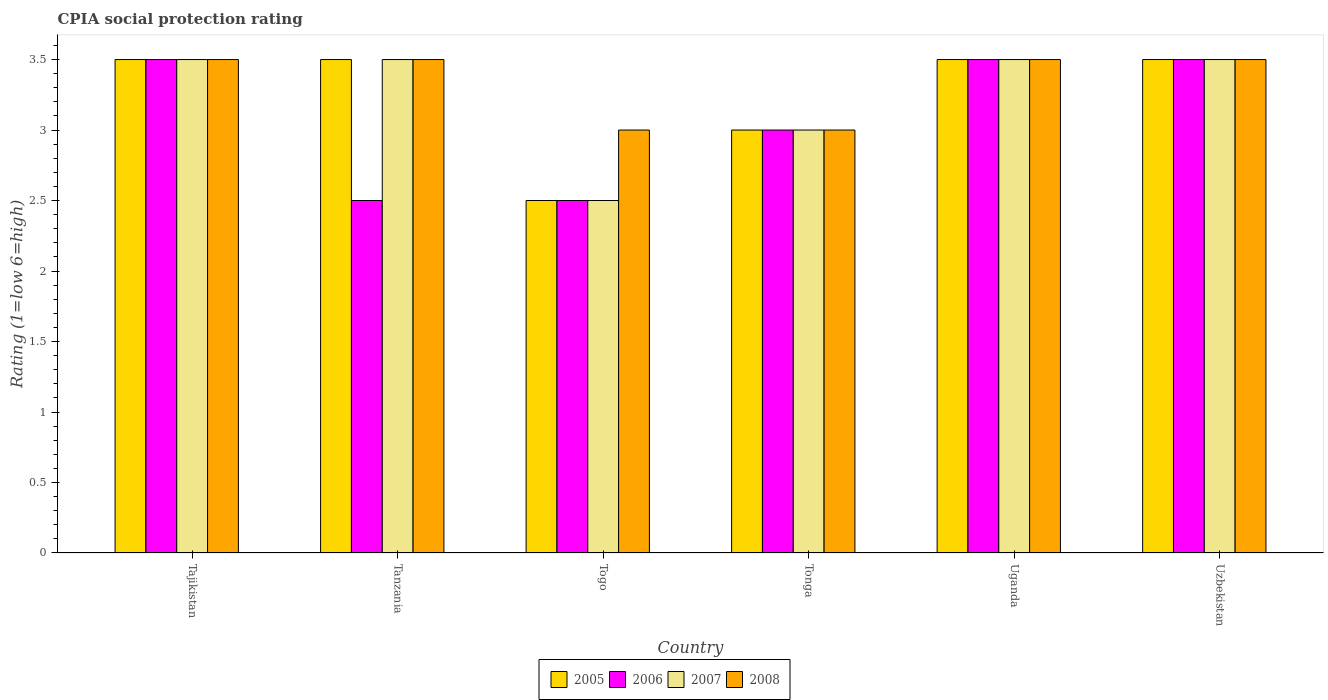How many groups of bars are there?
Ensure brevity in your answer.  6. How many bars are there on the 4th tick from the left?
Ensure brevity in your answer.  4. What is the label of the 2nd group of bars from the left?
Your response must be concise. Tanzania. In how many cases, is the number of bars for a given country not equal to the number of legend labels?
Your answer should be compact. 0. Across all countries, what is the maximum CPIA rating in 2005?
Provide a succinct answer. 3.5. Across all countries, what is the minimum CPIA rating in 2005?
Make the answer very short. 2.5. In which country was the CPIA rating in 2008 maximum?
Provide a succinct answer. Tajikistan. In which country was the CPIA rating in 2006 minimum?
Ensure brevity in your answer.  Tanzania. What is the average CPIA rating in 2007 per country?
Your answer should be very brief. 3.25. What is the difference between the CPIA rating of/in 2007 and CPIA rating of/in 2005 in Togo?
Keep it short and to the point. 0. In how many countries, is the CPIA rating in 2005 greater than 1.3?
Your response must be concise. 6. What is the ratio of the CPIA rating in 2007 in Togo to that in Uganda?
Offer a very short reply. 0.71. What is the difference between the highest and the lowest CPIA rating in 2005?
Your answer should be compact. 1. Is the sum of the CPIA rating in 2006 in Togo and Uganda greater than the maximum CPIA rating in 2005 across all countries?
Your answer should be compact. Yes. Is it the case that in every country, the sum of the CPIA rating in 2007 and CPIA rating in 2005 is greater than the sum of CPIA rating in 2006 and CPIA rating in 2008?
Your response must be concise. No. What does the 4th bar from the left in Uzbekistan represents?
Provide a succinct answer. 2008. What does the 3rd bar from the right in Tajikistan represents?
Offer a terse response. 2006. What is the difference between two consecutive major ticks on the Y-axis?
Give a very brief answer. 0.5. Are the values on the major ticks of Y-axis written in scientific E-notation?
Make the answer very short. No. Does the graph contain grids?
Your response must be concise. No. How are the legend labels stacked?
Ensure brevity in your answer.  Horizontal. What is the title of the graph?
Provide a succinct answer. CPIA social protection rating. What is the label or title of the X-axis?
Provide a succinct answer. Country. What is the Rating (1=low 6=high) in 2007 in Tajikistan?
Ensure brevity in your answer.  3.5. What is the Rating (1=low 6=high) of 2008 in Tajikistan?
Give a very brief answer. 3.5. What is the Rating (1=low 6=high) of 2008 in Tanzania?
Keep it short and to the point. 3.5. What is the Rating (1=low 6=high) in 2005 in Togo?
Ensure brevity in your answer.  2.5. What is the Rating (1=low 6=high) in 2008 in Togo?
Your answer should be compact. 3. What is the Rating (1=low 6=high) in 2006 in Tonga?
Keep it short and to the point. 3. What is the Rating (1=low 6=high) in 2007 in Tonga?
Give a very brief answer. 3. What is the Rating (1=low 6=high) in 2008 in Tonga?
Ensure brevity in your answer.  3. What is the Rating (1=low 6=high) in 2005 in Uganda?
Provide a succinct answer. 3.5. What is the Rating (1=low 6=high) of 2006 in Uganda?
Your answer should be very brief. 3.5. What is the Rating (1=low 6=high) of 2007 in Uganda?
Your answer should be very brief. 3.5. What is the Rating (1=low 6=high) in 2008 in Uganda?
Your response must be concise. 3.5. What is the Rating (1=low 6=high) of 2008 in Uzbekistan?
Provide a short and direct response. 3.5. Across all countries, what is the maximum Rating (1=low 6=high) of 2005?
Offer a terse response. 3.5. Across all countries, what is the maximum Rating (1=low 6=high) of 2007?
Offer a terse response. 3.5. Across all countries, what is the maximum Rating (1=low 6=high) in 2008?
Keep it short and to the point. 3.5. Across all countries, what is the minimum Rating (1=low 6=high) in 2005?
Offer a very short reply. 2.5. Across all countries, what is the minimum Rating (1=low 6=high) of 2006?
Keep it short and to the point. 2.5. Across all countries, what is the minimum Rating (1=low 6=high) in 2007?
Ensure brevity in your answer.  2.5. What is the total Rating (1=low 6=high) of 2005 in the graph?
Give a very brief answer. 19.5. What is the total Rating (1=low 6=high) of 2007 in the graph?
Make the answer very short. 19.5. What is the difference between the Rating (1=low 6=high) in 2005 in Tajikistan and that in Tanzania?
Offer a very short reply. 0. What is the difference between the Rating (1=low 6=high) in 2006 in Tajikistan and that in Tanzania?
Your answer should be compact. 1. What is the difference between the Rating (1=low 6=high) of 2008 in Tajikistan and that in Tanzania?
Give a very brief answer. 0. What is the difference between the Rating (1=low 6=high) of 2006 in Tajikistan and that in Togo?
Ensure brevity in your answer.  1. What is the difference between the Rating (1=low 6=high) of 2006 in Tajikistan and that in Tonga?
Give a very brief answer. 0.5. What is the difference between the Rating (1=low 6=high) in 2007 in Tajikistan and that in Tonga?
Your answer should be very brief. 0.5. What is the difference between the Rating (1=low 6=high) of 2008 in Tajikistan and that in Tonga?
Give a very brief answer. 0.5. What is the difference between the Rating (1=low 6=high) in 2005 in Tajikistan and that in Uganda?
Offer a very short reply. 0. What is the difference between the Rating (1=low 6=high) of 2006 in Tajikistan and that in Uganda?
Offer a very short reply. 0. What is the difference between the Rating (1=low 6=high) of 2007 in Tajikistan and that in Uganda?
Provide a succinct answer. 0. What is the difference between the Rating (1=low 6=high) in 2008 in Tajikistan and that in Uganda?
Your answer should be compact. 0. What is the difference between the Rating (1=low 6=high) in 2005 in Tajikistan and that in Uzbekistan?
Keep it short and to the point. 0. What is the difference between the Rating (1=low 6=high) in 2007 in Tajikistan and that in Uzbekistan?
Offer a terse response. 0. What is the difference between the Rating (1=low 6=high) of 2006 in Tanzania and that in Togo?
Your answer should be compact. 0. What is the difference between the Rating (1=low 6=high) in 2007 in Tanzania and that in Togo?
Make the answer very short. 1. What is the difference between the Rating (1=low 6=high) in 2008 in Tanzania and that in Togo?
Give a very brief answer. 0.5. What is the difference between the Rating (1=low 6=high) of 2007 in Tanzania and that in Tonga?
Offer a terse response. 0.5. What is the difference between the Rating (1=low 6=high) in 2006 in Tanzania and that in Uganda?
Offer a very short reply. -1. What is the difference between the Rating (1=low 6=high) in 2007 in Tanzania and that in Uganda?
Provide a short and direct response. 0. What is the difference between the Rating (1=low 6=high) of 2008 in Tanzania and that in Uganda?
Give a very brief answer. 0. What is the difference between the Rating (1=low 6=high) of 2008 in Togo and that in Tonga?
Give a very brief answer. 0. What is the difference between the Rating (1=low 6=high) of 2005 in Togo and that in Uzbekistan?
Give a very brief answer. -1. What is the difference between the Rating (1=low 6=high) in 2007 in Togo and that in Uzbekistan?
Keep it short and to the point. -1. What is the difference between the Rating (1=low 6=high) of 2008 in Togo and that in Uzbekistan?
Make the answer very short. -0.5. What is the difference between the Rating (1=low 6=high) of 2005 in Tonga and that in Uganda?
Your response must be concise. -0.5. What is the difference between the Rating (1=low 6=high) in 2007 in Tonga and that in Uganda?
Make the answer very short. -0.5. What is the difference between the Rating (1=low 6=high) in 2005 in Tonga and that in Uzbekistan?
Provide a succinct answer. -0.5. What is the difference between the Rating (1=low 6=high) in 2007 in Tonga and that in Uzbekistan?
Offer a very short reply. -0.5. What is the difference between the Rating (1=low 6=high) of 2005 in Uganda and that in Uzbekistan?
Make the answer very short. 0. What is the difference between the Rating (1=low 6=high) of 2006 in Uganda and that in Uzbekistan?
Your response must be concise. 0. What is the difference between the Rating (1=low 6=high) of 2006 in Tajikistan and the Rating (1=low 6=high) of 2007 in Tanzania?
Ensure brevity in your answer.  0. What is the difference between the Rating (1=low 6=high) of 2007 in Tajikistan and the Rating (1=low 6=high) of 2008 in Tanzania?
Give a very brief answer. 0. What is the difference between the Rating (1=low 6=high) of 2005 in Tajikistan and the Rating (1=low 6=high) of 2007 in Togo?
Make the answer very short. 1. What is the difference between the Rating (1=low 6=high) in 2005 in Tajikistan and the Rating (1=low 6=high) in 2008 in Togo?
Keep it short and to the point. 0.5. What is the difference between the Rating (1=low 6=high) of 2006 in Tajikistan and the Rating (1=low 6=high) of 2007 in Togo?
Provide a succinct answer. 1. What is the difference between the Rating (1=low 6=high) in 2006 in Tajikistan and the Rating (1=low 6=high) in 2008 in Togo?
Your answer should be very brief. 0.5. What is the difference between the Rating (1=low 6=high) of 2005 in Tajikistan and the Rating (1=low 6=high) of 2007 in Tonga?
Make the answer very short. 0.5. What is the difference between the Rating (1=low 6=high) of 2005 in Tajikistan and the Rating (1=low 6=high) of 2008 in Tonga?
Provide a short and direct response. 0.5. What is the difference between the Rating (1=low 6=high) in 2006 in Tajikistan and the Rating (1=low 6=high) in 2007 in Tonga?
Your answer should be very brief. 0.5. What is the difference between the Rating (1=low 6=high) in 2005 in Tajikistan and the Rating (1=low 6=high) in 2006 in Uganda?
Offer a terse response. 0. What is the difference between the Rating (1=low 6=high) in 2005 in Tajikistan and the Rating (1=low 6=high) in 2008 in Uganda?
Your response must be concise. 0. What is the difference between the Rating (1=low 6=high) in 2006 in Tajikistan and the Rating (1=low 6=high) in 2007 in Uganda?
Give a very brief answer. 0. What is the difference between the Rating (1=low 6=high) of 2007 in Tajikistan and the Rating (1=low 6=high) of 2008 in Uganda?
Your answer should be compact. 0. What is the difference between the Rating (1=low 6=high) in 2005 in Tajikistan and the Rating (1=low 6=high) in 2007 in Uzbekistan?
Your response must be concise. 0. What is the difference between the Rating (1=low 6=high) in 2007 in Tajikistan and the Rating (1=low 6=high) in 2008 in Uzbekistan?
Offer a very short reply. 0. What is the difference between the Rating (1=low 6=high) in 2005 in Tanzania and the Rating (1=low 6=high) in 2007 in Togo?
Keep it short and to the point. 1. What is the difference between the Rating (1=low 6=high) in 2005 in Tanzania and the Rating (1=low 6=high) in 2008 in Togo?
Your answer should be very brief. 0.5. What is the difference between the Rating (1=low 6=high) in 2007 in Tanzania and the Rating (1=low 6=high) in 2008 in Togo?
Your answer should be very brief. 0.5. What is the difference between the Rating (1=low 6=high) of 2005 in Tanzania and the Rating (1=low 6=high) of 2006 in Tonga?
Offer a very short reply. 0.5. What is the difference between the Rating (1=low 6=high) of 2005 in Tanzania and the Rating (1=low 6=high) of 2007 in Uganda?
Your response must be concise. 0. What is the difference between the Rating (1=low 6=high) of 2005 in Tanzania and the Rating (1=low 6=high) of 2008 in Uganda?
Keep it short and to the point. 0. What is the difference between the Rating (1=low 6=high) of 2005 in Tanzania and the Rating (1=low 6=high) of 2007 in Uzbekistan?
Your response must be concise. 0. What is the difference between the Rating (1=low 6=high) of 2006 in Tanzania and the Rating (1=low 6=high) of 2008 in Uzbekistan?
Make the answer very short. -1. What is the difference between the Rating (1=low 6=high) of 2005 in Togo and the Rating (1=low 6=high) of 2008 in Tonga?
Keep it short and to the point. -0.5. What is the difference between the Rating (1=low 6=high) of 2006 in Togo and the Rating (1=low 6=high) of 2007 in Tonga?
Keep it short and to the point. -0.5. What is the difference between the Rating (1=low 6=high) in 2007 in Togo and the Rating (1=low 6=high) in 2008 in Tonga?
Make the answer very short. -0.5. What is the difference between the Rating (1=low 6=high) in 2005 in Togo and the Rating (1=low 6=high) in 2006 in Uganda?
Make the answer very short. -1. What is the difference between the Rating (1=low 6=high) of 2005 in Togo and the Rating (1=low 6=high) of 2008 in Uganda?
Your response must be concise. -1. What is the difference between the Rating (1=low 6=high) of 2005 in Togo and the Rating (1=low 6=high) of 2007 in Uzbekistan?
Make the answer very short. -1. What is the difference between the Rating (1=low 6=high) in 2005 in Togo and the Rating (1=low 6=high) in 2008 in Uzbekistan?
Offer a very short reply. -1. What is the difference between the Rating (1=low 6=high) of 2006 in Togo and the Rating (1=low 6=high) of 2007 in Uzbekistan?
Keep it short and to the point. -1. What is the difference between the Rating (1=low 6=high) in 2006 in Togo and the Rating (1=low 6=high) in 2008 in Uzbekistan?
Keep it short and to the point. -1. What is the difference between the Rating (1=low 6=high) in 2007 in Togo and the Rating (1=low 6=high) in 2008 in Uzbekistan?
Ensure brevity in your answer.  -1. What is the difference between the Rating (1=low 6=high) of 2005 in Tonga and the Rating (1=low 6=high) of 2008 in Uganda?
Ensure brevity in your answer.  -0.5. What is the difference between the Rating (1=low 6=high) of 2006 in Tonga and the Rating (1=low 6=high) of 2008 in Uganda?
Your answer should be compact. -0.5. What is the difference between the Rating (1=low 6=high) in 2007 in Tonga and the Rating (1=low 6=high) in 2008 in Uganda?
Keep it short and to the point. -0.5. What is the difference between the Rating (1=low 6=high) of 2005 in Tonga and the Rating (1=low 6=high) of 2006 in Uzbekistan?
Your answer should be very brief. -0.5. What is the difference between the Rating (1=low 6=high) in 2005 in Tonga and the Rating (1=low 6=high) in 2007 in Uzbekistan?
Give a very brief answer. -0.5. What is the difference between the Rating (1=low 6=high) of 2006 in Tonga and the Rating (1=low 6=high) of 2007 in Uzbekistan?
Offer a terse response. -0.5. What is the difference between the Rating (1=low 6=high) in 2007 in Tonga and the Rating (1=low 6=high) in 2008 in Uzbekistan?
Keep it short and to the point. -0.5. What is the difference between the Rating (1=low 6=high) in 2005 in Uganda and the Rating (1=low 6=high) in 2006 in Uzbekistan?
Offer a very short reply. 0. What is the difference between the Rating (1=low 6=high) of 2005 in Uganda and the Rating (1=low 6=high) of 2007 in Uzbekistan?
Make the answer very short. 0. What is the difference between the Rating (1=low 6=high) of 2005 in Uganda and the Rating (1=low 6=high) of 2008 in Uzbekistan?
Your answer should be very brief. 0. What is the difference between the Rating (1=low 6=high) of 2006 in Uganda and the Rating (1=low 6=high) of 2008 in Uzbekistan?
Provide a short and direct response. 0. What is the average Rating (1=low 6=high) of 2005 per country?
Provide a succinct answer. 3.25. What is the average Rating (1=low 6=high) in 2006 per country?
Provide a succinct answer. 3.08. What is the average Rating (1=low 6=high) in 2008 per country?
Give a very brief answer. 3.33. What is the difference between the Rating (1=low 6=high) of 2006 and Rating (1=low 6=high) of 2007 in Tajikistan?
Make the answer very short. 0. What is the difference between the Rating (1=low 6=high) in 2006 and Rating (1=low 6=high) in 2008 in Tajikistan?
Your response must be concise. 0. What is the difference between the Rating (1=low 6=high) of 2007 and Rating (1=low 6=high) of 2008 in Tajikistan?
Make the answer very short. 0. What is the difference between the Rating (1=low 6=high) of 2005 and Rating (1=low 6=high) of 2007 in Tanzania?
Give a very brief answer. 0. What is the difference between the Rating (1=low 6=high) in 2005 and Rating (1=low 6=high) in 2008 in Tanzania?
Make the answer very short. 0. What is the difference between the Rating (1=low 6=high) of 2006 and Rating (1=low 6=high) of 2007 in Tanzania?
Your answer should be very brief. -1. What is the difference between the Rating (1=low 6=high) in 2005 and Rating (1=low 6=high) in 2006 in Togo?
Your answer should be compact. 0. What is the difference between the Rating (1=low 6=high) of 2005 and Rating (1=low 6=high) of 2008 in Tonga?
Provide a short and direct response. 0. What is the difference between the Rating (1=low 6=high) of 2007 and Rating (1=low 6=high) of 2008 in Tonga?
Provide a short and direct response. 0. What is the difference between the Rating (1=low 6=high) in 2005 and Rating (1=low 6=high) in 2008 in Uganda?
Give a very brief answer. 0. What is the difference between the Rating (1=low 6=high) of 2006 and Rating (1=low 6=high) of 2007 in Uganda?
Provide a short and direct response. 0. What is the difference between the Rating (1=low 6=high) in 2007 and Rating (1=low 6=high) in 2008 in Uganda?
Your response must be concise. 0. What is the difference between the Rating (1=low 6=high) of 2005 and Rating (1=low 6=high) of 2006 in Uzbekistan?
Your response must be concise. 0. What is the difference between the Rating (1=low 6=high) in 2005 and Rating (1=low 6=high) in 2007 in Uzbekistan?
Offer a very short reply. 0. What is the difference between the Rating (1=low 6=high) of 2006 and Rating (1=low 6=high) of 2008 in Uzbekistan?
Offer a terse response. 0. What is the ratio of the Rating (1=low 6=high) of 2008 in Tajikistan to that in Tanzania?
Your answer should be compact. 1. What is the ratio of the Rating (1=low 6=high) of 2005 in Tajikistan to that in Togo?
Give a very brief answer. 1.4. What is the ratio of the Rating (1=low 6=high) of 2006 in Tajikistan to that in Togo?
Offer a very short reply. 1.4. What is the ratio of the Rating (1=low 6=high) in 2007 in Tajikistan to that in Togo?
Ensure brevity in your answer.  1.4. What is the ratio of the Rating (1=low 6=high) of 2005 in Tajikistan to that in Tonga?
Provide a succinct answer. 1.17. What is the ratio of the Rating (1=low 6=high) in 2006 in Tajikistan to that in Tonga?
Offer a terse response. 1.17. What is the ratio of the Rating (1=low 6=high) of 2008 in Tajikistan to that in Tonga?
Your answer should be compact. 1.17. What is the ratio of the Rating (1=low 6=high) in 2006 in Tajikistan to that in Uganda?
Give a very brief answer. 1. What is the ratio of the Rating (1=low 6=high) in 2005 in Tajikistan to that in Uzbekistan?
Give a very brief answer. 1. What is the ratio of the Rating (1=low 6=high) in 2007 in Tajikistan to that in Uzbekistan?
Offer a terse response. 1. What is the ratio of the Rating (1=low 6=high) of 2008 in Tajikistan to that in Uzbekistan?
Your answer should be compact. 1. What is the ratio of the Rating (1=low 6=high) in 2007 in Tanzania to that in Togo?
Your answer should be very brief. 1.4. What is the ratio of the Rating (1=low 6=high) in 2008 in Tanzania to that in Togo?
Make the answer very short. 1.17. What is the ratio of the Rating (1=low 6=high) in 2006 in Tanzania to that in Tonga?
Your response must be concise. 0.83. What is the ratio of the Rating (1=low 6=high) in 2008 in Tanzania to that in Tonga?
Offer a very short reply. 1.17. What is the ratio of the Rating (1=low 6=high) of 2006 in Tanzania to that in Uganda?
Offer a terse response. 0.71. What is the ratio of the Rating (1=low 6=high) of 2008 in Tanzania to that in Uganda?
Give a very brief answer. 1. What is the ratio of the Rating (1=low 6=high) in 2007 in Tanzania to that in Uzbekistan?
Provide a succinct answer. 1. What is the ratio of the Rating (1=low 6=high) in 2006 in Togo to that in Tonga?
Give a very brief answer. 0.83. What is the ratio of the Rating (1=low 6=high) in 2008 in Togo to that in Tonga?
Make the answer very short. 1. What is the ratio of the Rating (1=low 6=high) in 2007 in Togo to that in Uganda?
Offer a very short reply. 0.71. What is the ratio of the Rating (1=low 6=high) in 2008 in Togo to that in Uganda?
Offer a terse response. 0.86. What is the ratio of the Rating (1=low 6=high) in 2005 in Togo to that in Uzbekistan?
Ensure brevity in your answer.  0.71. What is the ratio of the Rating (1=low 6=high) in 2008 in Togo to that in Uzbekistan?
Offer a very short reply. 0.86. What is the ratio of the Rating (1=low 6=high) of 2008 in Tonga to that in Uganda?
Offer a very short reply. 0.86. What is the ratio of the Rating (1=low 6=high) of 2005 in Tonga to that in Uzbekistan?
Provide a succinct answer. 0.86. What is the ratio of the Rating (1=low 6=high) in 2006 in Tonga to that in Uzbekistan?
Provide a short and direct response. 0.86. What is the ratio of the Rating (1=low 6=high) of 2008 in Tonga to that in Uzbekistan?
Offer a terse response. 0.86. What is the ratio of the Rating (1=low 6=high) in 2005 in Uganda to that in Uzbekistan?
Your response must be concise. 1. What is the ratio of the Rating (1=low 6=high) of 2006 in Uganda to that in Uzbekistan?
Ensure brevity in your answer.  1. What is the ratio of the Rating (1=low 6=high) in 2007 in Uganda to that in Uzbekistan?
Offer a terse response. 1. What is the difference between the highest and the second highest Rating (1=low 6=high) in 2005?
Your answer should be compact. 0. What is the difference between the highest and the second highest Rating (1=low 6=high) in 2006?
Give a very brief answer. 0. What is the difference between the highest and the second highest Rating (1=low 6=high) in 2008?
Your answer should be very brief. 0. What is the difference between the highest and the lowest Rating (1=low 6=high) of 2005?
Offer a terse response. 1. What is the difference between the highest and the lowest Rating (1=low 6=high) of 2007?
Provide a short and direct response. 1. What is the difference between the highest and the lowest Rating (1=low 6=high) of 2008?
Provide a succinct answer. 0.5. 